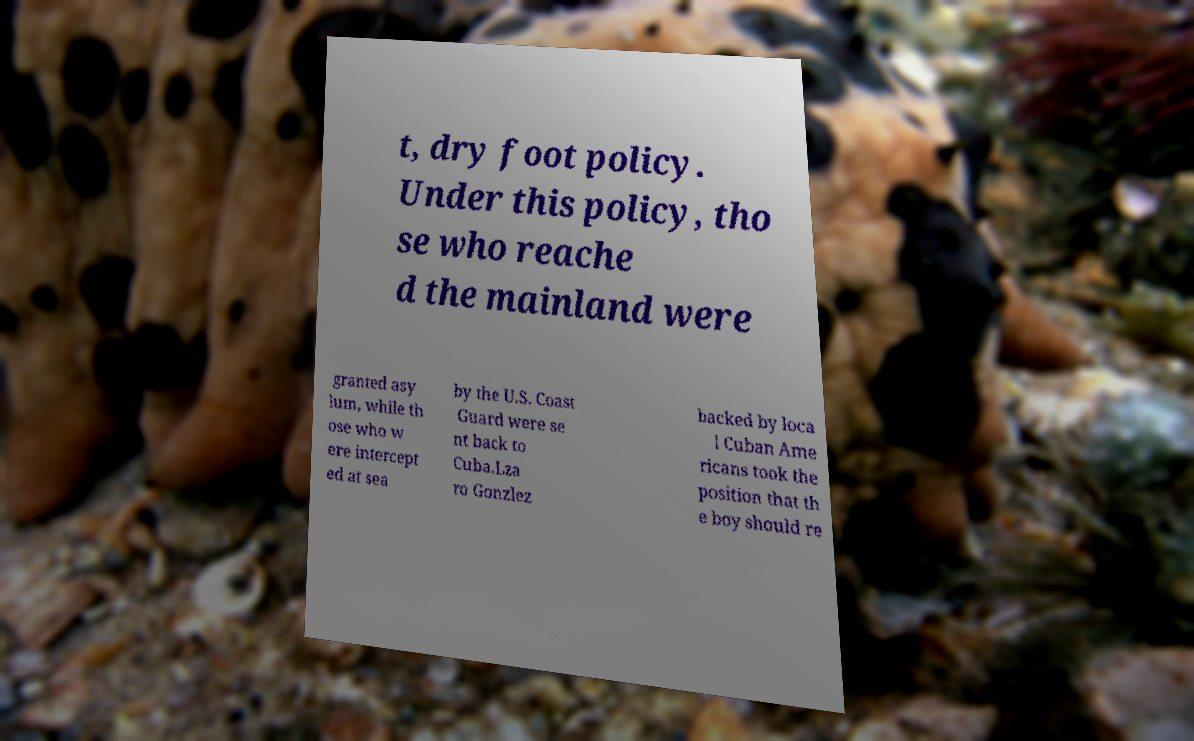What messages or text are displayed in this image? I need them in a readable, typed format. t, dry foot policy. Under this policy, tho se who reache d the mainland were granted asy lum, while th ose who w ere intercept ed at sea by the U.S. Coast Guard were se nt back to Cuba.Lza ro Gonzlez backed by loca l Cuban Ame ricans took the position that th e boy should re 